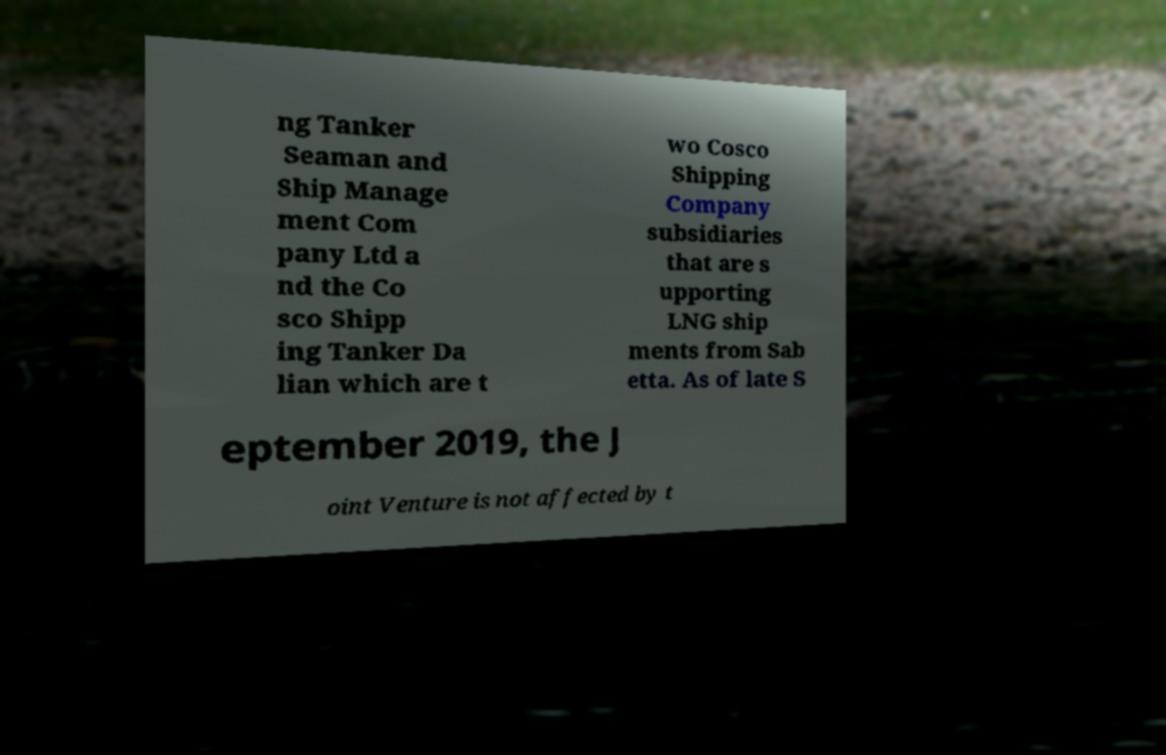Could you assist in decoding the text presented in this image and type it out clearly? ng Tanker Seaman and Ship Manage ment Com pany Ltd a nd the Co sco Shipp ing Tanker Da lian which are t wo Cosco Shipping Company subsidiaries that are s upporting LNG ship ments from Sab etta. As of late S eptember 2019, the J oint Venture is not affected by t 